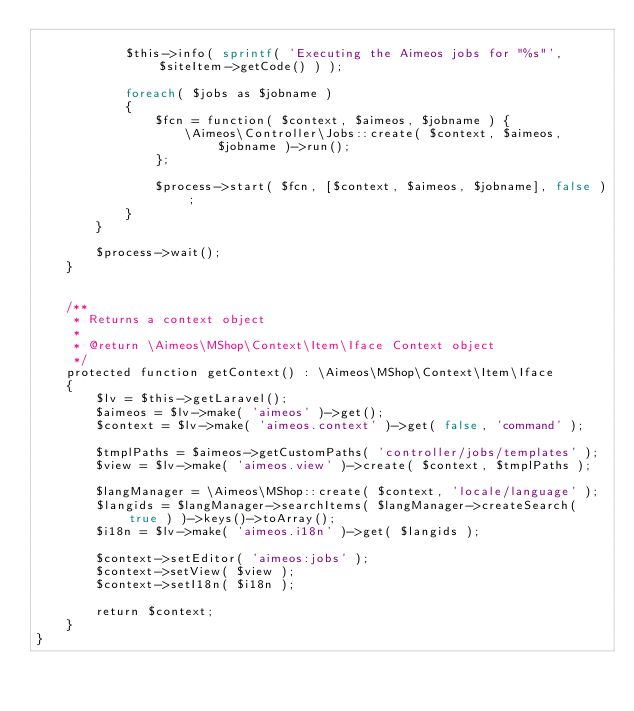<code> <loc_0><loc_0><loc_500><loc_500><_PHP_>
			$this->info( sprintf( 'Executing the Aimeos jobs for "%s"', $siteItem->getCode() ) );

			foreach( $jobs as $jobname )
			{
				$fcn = function( $context, $aimeos, $jobname ) {
					\Aimeos\Controller\Jobs::create( $context, $aimeos, $jobname )->run();
				};

				$process->start( $fcn, [$context, $aimeos, $jobname], false );
			}
		}

		$process->wait();
	}


	/**
	 * Returns a context object
	 *
	 * @return \Aimeos\MShop\Context\Item\Iface Context object
	 */
	protected function getContext() : \Aimeos\MShop\Context\Item\Iface
	{
		$lv = $this->getLaravel();
		$aimeos = $lv->make( 'aimeos' )->get();
		$context = $lv->make( 'aimeos.context' )->get( false, 'command' );

		$tmplPaths = $aimeos->getCustomPaths( 'controller/jobs/templates' );
		$view = $lv->make( 'aimeos.view' )->create( $context, $tmplPaths );

		$langManager = \Aimeos\MShop::create( $context, 'locale/language' );
		$langids = $langManager->searchItems( $langManager->createSearch( true ) )->keys()->toArray();
		$i18n = $lv->make( 'aimeos.i18n' )->get( $langids );

		$context->setEditor( 'aimeos:jobs' );
		$context->setView( $view );
		$context->setI18n( $i18n );

		return $context;
	}
}
</code> 